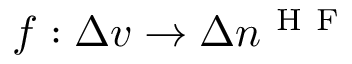<formula> <loc_0><loc_0><loc_500><loc_500>f \colon \Delta v \to \Delta n ^ { H F }</formula> 